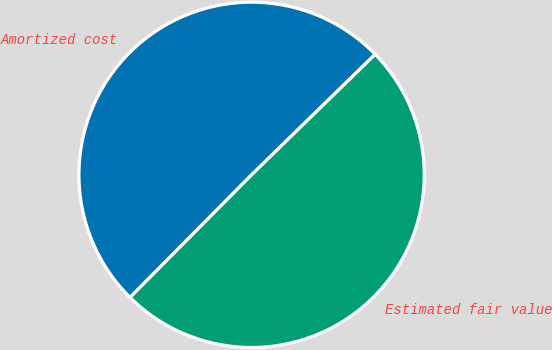<chart> <loc_0><loc_0><loc_500><loc_500><pie_chart><fcel>Amortized cost<fcel>Estimated fair value<nl><fcel>50.27%<fcel>49.73%<nl></chart> 